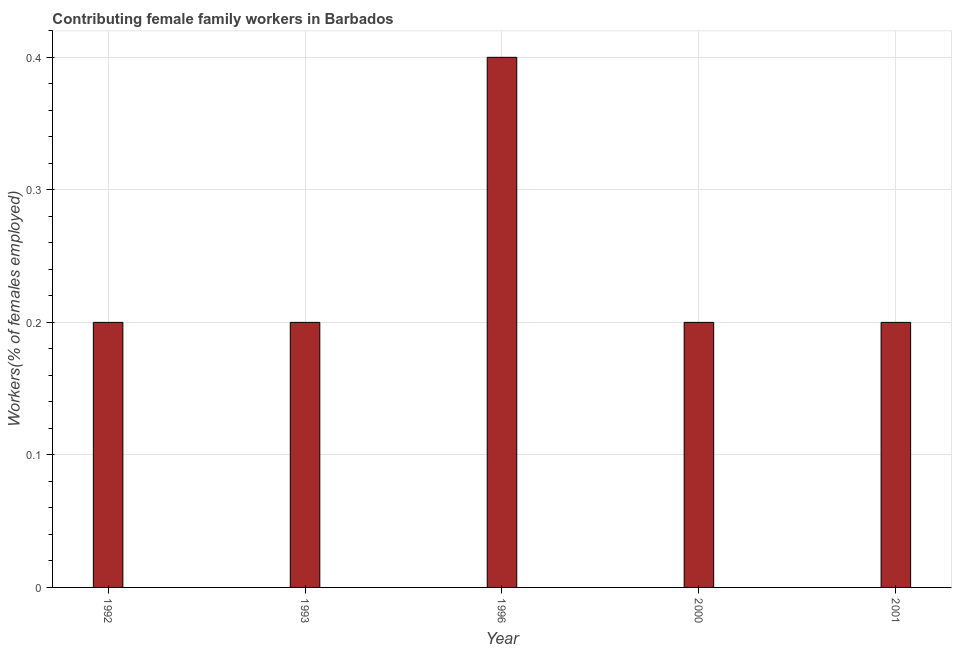What is the title of the graph?
Provide a succinct answer. Contributing female family workers in Barbados. What is the label or title of the X-axis?
Make the answer very short. Year. What is the label or title of the Y-axis?
Your answer should be very brief. Workers(% of females employed). What is the contributing female family workers in 2000?
Keep it short and to the point. 0.2. Across all years, what is the maximum contributing female family workers?
Your response must be concise. 0.4. Across all years, what is the minimum contributing female family workers?
Ensure brevity in your answer.  0.2. In which year was the contributing female family workers minimum?
Your answer should be very brief. 1992. What is the sum of the contributing female family workers?
Offer a terse response. 1.2. What is the average contributing female family workers per year?
Ensure brevity in your answer.  0.24. What is the median contributing female family workers?
Your answer should be very brief. 0.2. In how many years, is the contributing female family workers greater than 0.02 %?
Provide a succinct answer. 5. Do a majority of the years between 1992 and 1996 (inclusive) have contributing female family workers greater than 0.26 %?
Offer a terse response. No. Is the difference between the contributing female family workers in 1992 and 2000 greater than the difference between any two years?
Provide a succinct answer. No. Is the sum of the contributing female family workers in 1993 and 2001 greater than the maximum contributing female family workers across all years?
Provide a short and direct response. No. How many bars are there?
Give a very brief answer. 5. Are the values on the major ticks of Y-axis written in scientific E-notation?
Ensure brevity in your answer.  No. What is the Workers(% of females employed) in 1992?
Keep it short and to the point. 0.2. What is the Workers(% of females employed) in 1993?
Ensure brevity in your answer.  0.2. What is the Workers(% of females employed) in 1996?
Offer a very short reply. 0.4. What is the Workers(% of females employed) in 2000?
Keep it short and to the point. 0.2. What is the Workers(% of females employed) of 2001?
Make the answer very short. 0.2. What is the difference between the Workers(% of females employed) in 1992 and 1993?
Your answer should be very brief. 0. What is the difference between the Workers(% of females employed) in 1992 and 2001?
Ensure brevity in your answer.  0. What is the difference between the Workers(% of females employed) in 1993 and 2000?
Keep it short and to the point. 0. What is the difference between the Workers(% of females employed) in 1993 and 2001?
Give a very brief answer. 0. What is the difference between the Workers(% of females employed) in 1996 and 2000?
Keep it short and to the point. 0.2. What is the difference between the Workers(% of females employed) in 1996 and 2001?
Give a very brief answer. 0.2. What is the difference between the Workers(% of females employed) in 2000 and 2001?
Ensure brevity in your answer.  0. What is the ratio of the Workers(% of females employed) in 1992 to that in 1996?
Make the answer very short. 0.5. What is the ratio of the Workers(% of females employed) in 1992 to that in 2001?
Keep it short and to the point. 1. What is the ratio of the Workers(% of females employed) in 1993 to that in 1996?
Give a very brief answer. 0.5. What is the ratio of the Workers(% of females employed) in 1993 to that in 2001?
Ensure brevity in your answer.  1. What is the ratio of the Workers(% of females employed) in 1996 to that in 2000?
Your answer should be very brief. 2. 